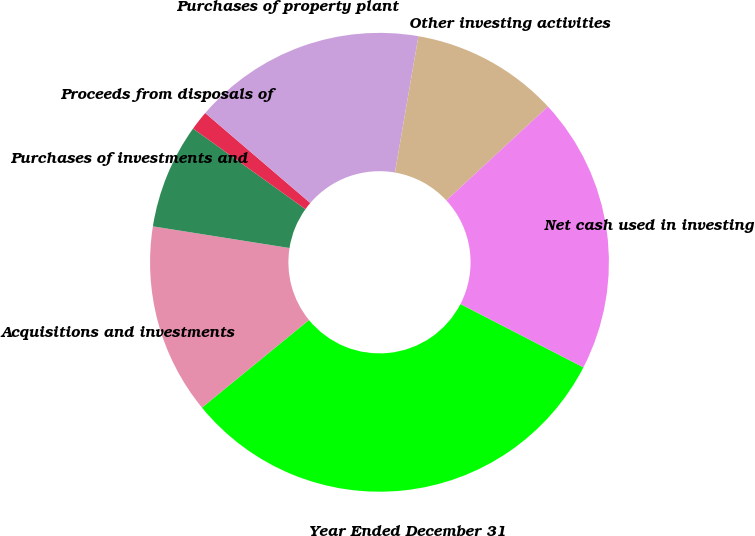<chart> <loc_0><loc_0><loc_500><loc_500><pie_chart><fcel>Year Ended December 31<fcel>Acquisitions and investments<fcel>Purchases of investments and<fcel>Proceeds from disposals of<fcel>Purchases of property plant<fcel>Other investing activities<fcel>Net cash used in investing<nl><fcel>31.51%<fcel>13.42%<fcel>7.4%<fcel>1.37%<fcel>16.44%<fcel>10.41%<fcel>19.45%<nl></chart> 